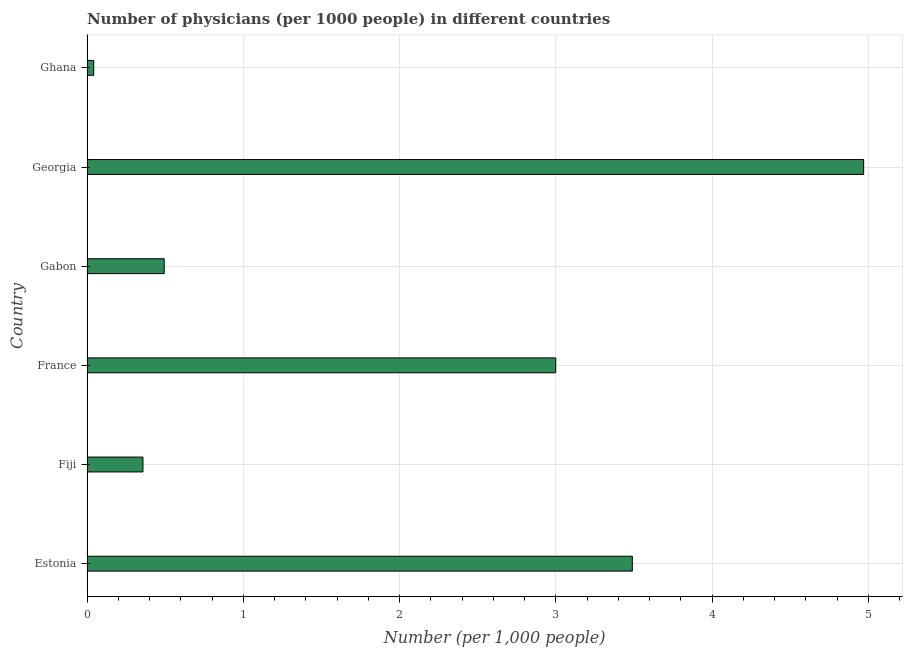Does the graph contain grids?
Keep it short and to the point. Yes. What is the title of the graph?
Provide a succinct answer. Number of physicians (per 1000 people) in different countries. What is the label or title of the X-axis?
Offer a very short reply. Number (per 1,0 people). What is the number of physicians in Georgia?
Ensure brevity in your answer.  4.97. Across all countries, what is the maximum number of physicians?
Keep it short and to the point. 4.97. Across all countries, what is the minimum number of physicians?
Provide a succinct answer. 0.04. In which country was the number of physicians maximum?
Your response must be concise. Georgia. In which country was the number of physicians minimum?
Keep it short and to the point. Ghana. What is the sum of the number of physicians?
Keep it short and to the point. 12.36. What is the difference between the number of physicians in France and Gabon?
Your response must be concise. 2.51. What is the average number of physicians per country?
Give a very brief answer. 2.06. What is the median number of physicians?
Your answer should be compact. 1.75. In how many countries, is the number of physicians greater than 3.2 ?
Offer a terse response. 2. What is the ratio of the number of physicians in Georgia to that in Ghana?
Make the answer very short. 115.59. Is the number of physicians in Estonia less than that in France?
Your response must be concise. No. Is the difference between the number of physicians in Gabon and Georgia greater than the difference between any two countries?
Provide a succinct answer. No. What is the difference between the highest and the second highest number of physicians?
Your answer should be compact. 1.48. What is the difference between the highest and the lowest number of physicians?
Give a very brief answer. 4.93. In how many countries, is the number of physicians greater than the average number of physicians taken over all countries?
Ensure brevity in your answer.  3. Are the values on the major ticks of X-axis written in scientific E-notation?
Make the answer very short. No. What is the Number (per 1,000 people) of Estonia?
Keep it short and to the point. 3.49. What is the Number (per 1,000 people) in Fiji?
Make the answer very short. 0.36. What is the Number (per 1,000 people) in France?
Provide a succinct answer. 3. What is the Number (per 1,000 people) of Gabon?
Keep it short and to the point. 0.49. What is the Number (per 1,000 people) in Georgia?
Provide a succinct answer. 4.97. What is the Number (per 1,000 people) in Ghana?
Your answer should be compact. 0.04. What is the difference between the Number (per 1,000 people) in Estonia and Fiji?
Provide a succinct answer. 3.13. What is the difference between the Number (per 1,000 people) in Estonia and France?
Your answer should be very brief. 0.49. What is the difference between the Number (per 1,000 people) in Estonia and Gabon?
Offer a terse response. 3. What is the difference between the Number (per 1,000 people) in Estonia and Georgia?
Keep it short and to the point. -1.48. What is the difference between the Number (per 1,000 people) in Estonia and Ghana?
Your answer should be compact. 3.45. What is the difference between the Number (per 1,000 people) in Fiji and France?
Offer a very short reply. -2.64. What is the difference between the Number (per 1,000 people) in Fiji and Gabon?
Provide a succinct answer. -0.14. What is the difference between the Number (per 1,000 people) in Fiji and Georgia?
Offer a terse response. -4.61. What is the difference between the Number (per 1,000 people) in Fiji and Ghana?
Your response must be concise. 0.32. What is the difference between the Number (per 1,000 people) in France and Gabon?
Your response must be concise. 2.51. What is the difference between the Number (per 1,000 people) in France and Georgia?
Provide a succinct answer. -1.97. What is the difference between the Number (per 1,000 people) in France and Ghana?
Give a very brief answer. 2.96. What is the difference between the Number (per 1,000 people) in Gabon and Georgia?
Make the answer very short. -4.48. What is the difference between the Number (per 1,000 people) in Gabon and Ghana?
Your answer should be compact. 0.45. What is the difference between the Number (per 1,000 people) in Georgia and Ghana?
Your response must be concise. 4.93. What is the ratio of the Number (per 1,000 people) in Estonia to that in Fiji?
Your answer should be very brief. 9.75. What is the ratio of the Number (per 1,000 people) in Estonia to that in France?
Your answer should be very brief. 1.16. What is the ratio of the Number (per 1,000 people) in Estonia to that in Gabon?
Provide a succinct answer. 7.06. What is the ratio of the Number (per 1,000 people) in Estonia to that in Georgia?
Your answer should be compact. 0.7. What is the ratio of the Number (per 1,000 people) in Estonia to that in Ghana?
Keep it short and to the point. 81.17. What is the ratio of the Number (per 1,000 people) in Fiji to that in France?
Your response must be concise. 0.12. What is the ratio of the Number (per 1,000 people) in Fiji to that in Gabon?
Ensure brevity in your answer.  0.72. What is the ratio of the Number (per 1,000 people) in Fiji to that in Georgia?
Your answer should be very brief. 0.07. What is the ratio of the Number (per 1,000 people) in Fiji to that in Ghana?
Provide a short and direct response. 8.33. What is the ratio of the Number (per 1,000 people) in France to that in Gabon?
Your answer should be very brief. 6.07. What is the ratio of the Number (per 1,000 people) in France to that in Georgia?
Make the answer very short. 0.6. What is the ratio of the Number (per 1,000 people) in France to that in Ghana?
Your response must be concise. 69.77. What is the ratio of the Number (per 1,000 people) in Gabon to that in Georgia?
Make the answer very short. 0.1. What is the ratio of the Number (per 1,000 people) in Gabon to that in Ghana?
Make the answer very short. 11.49. What is the ratio of the Number (per 1,000 people) in Georgia to that in Ghana?
Your response must be concise. 115.59. 